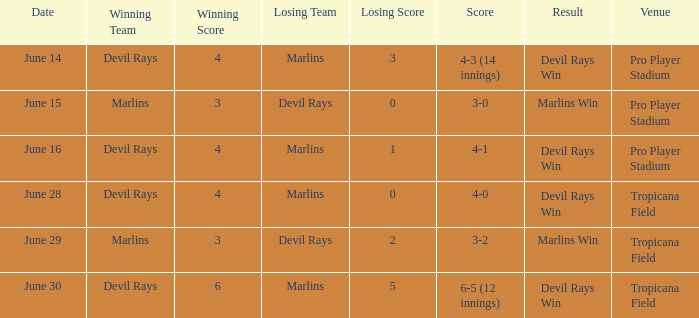What was the score on june 16? 4-1. 